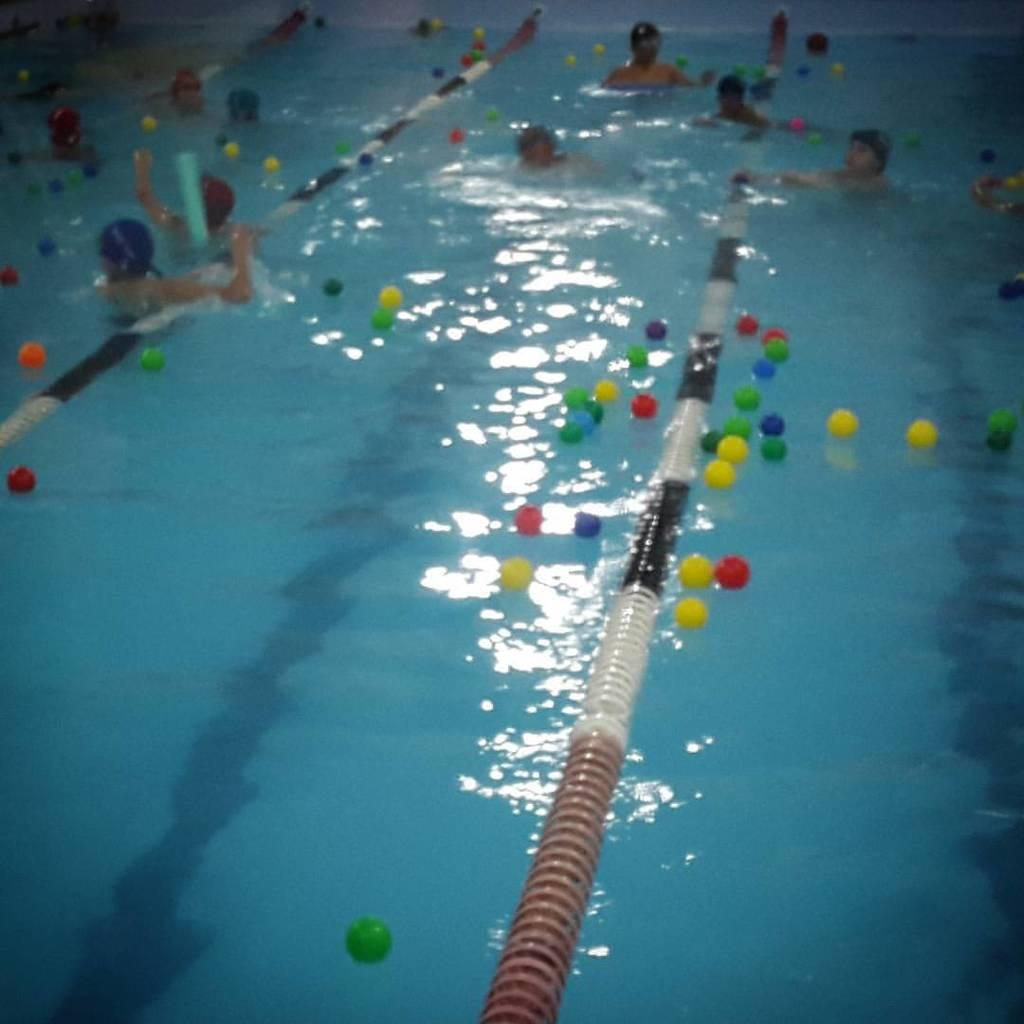What is the main feature of the image? There is a swimming pool in the picture. What are the people in the image doing? There are people swimming in the pool. What else can be seen floating on the surface of the water in the pool? There are balls floating on the surface of the water in the pool. What type of connection is being used by the girl in the image? There is no girl present in the image, and therefore no connection can be observed. 